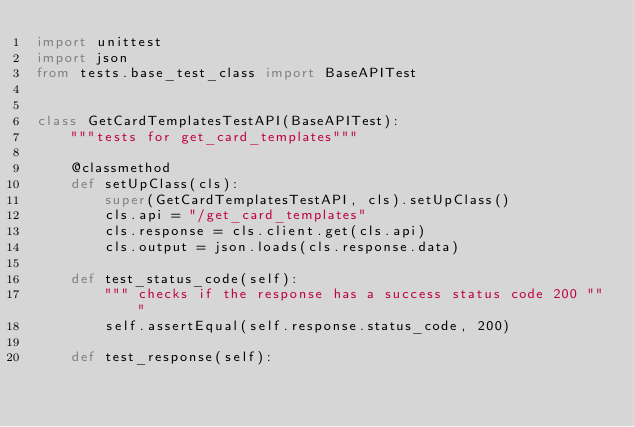<code> <loc_0><loc_0><loc_500><loc_500><_Python_>import unittest
import json
from tests.base_test_class import BaseAPITest


class GetCardTemplatesTestAPI(BaseAPITest):
    """tests for get_card_templates"""

    @classmethod
    def setUpClass(cls):
        super(GetCardTemplatesTestAPI, cls).setUpClass()
        cls.api = "/get_card_templates"
        cls.response = cls.client.get(cls.api)
        cls.output = json.loads(cls.response.data)

    def test_status_code(self):
        """ checks if the response has a success status code 200 """
        self.assertEqual(self.response.status_code, 200)

    def test_response(self):</code> 